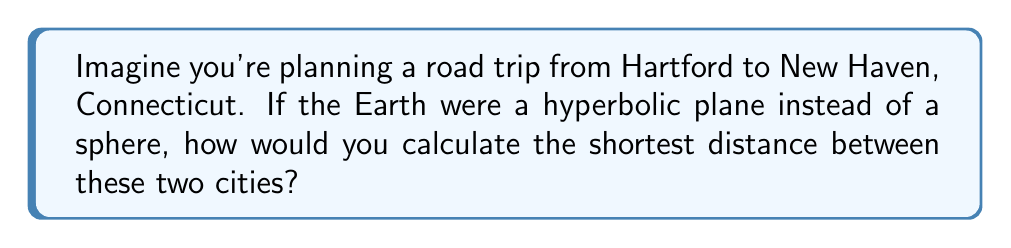Could you help me with this problem? To calculate the shortest distance between two points on a hyperbolic plane, we need to use the hyperbolic distance formula. Let's break it down step-by-step:

1. In hyperbolic geometry, we often use the Poincaré disk model. In this model, the hyperbolic plane is represented by the interior of a unit circle.

2. We need to convert the locations of Hartford and New Haven to coordinates in the Poincaré disk. Let's say Hartford is at point $A(x_1, y_1)$ and New Haven is at point $B(x_2, y_2)$.

3. The hyperbolic distance $d$ between two points $(x_1, y_1)$ and $(x_2, y_2)$ in the Poincaré disk is given by the formula:

   $$d = \text{arcosh}\left(1 + \frac{2(x_1-x_2)^2 + 2(y_1-y_2)^2}{(1-x_1^2-y_1^2)(1-x_2^2-y_2^2)}\right)$$

   Where $\text{arcosh}$ is the inverse hyperbolic cosine function.

4. To use this formula, we would need to:
   a. Determine the coordinates of Hartford and New Haven in the Poincaré disk.
   b. Plug these coordinates into the formula.
   c. Calculate the result using a scientific calculator or computer software.

5. The resulting value would give us the shortest distance between Hartford and New Haven on a hyperbolic plane.

It's important to note that this distance would be different from the distance on a flat plane or on the surface of a sphere (which is closer to the Earth's actual shape).
Answer: $d = \text{arcosh}\left(1 + \frac{2(x_1-x_2)^2 + 2(y_1-y_2)^2}{(1-x_1^2-y_1^2)(1-x_2^2-y_2^2)}\right)$ 